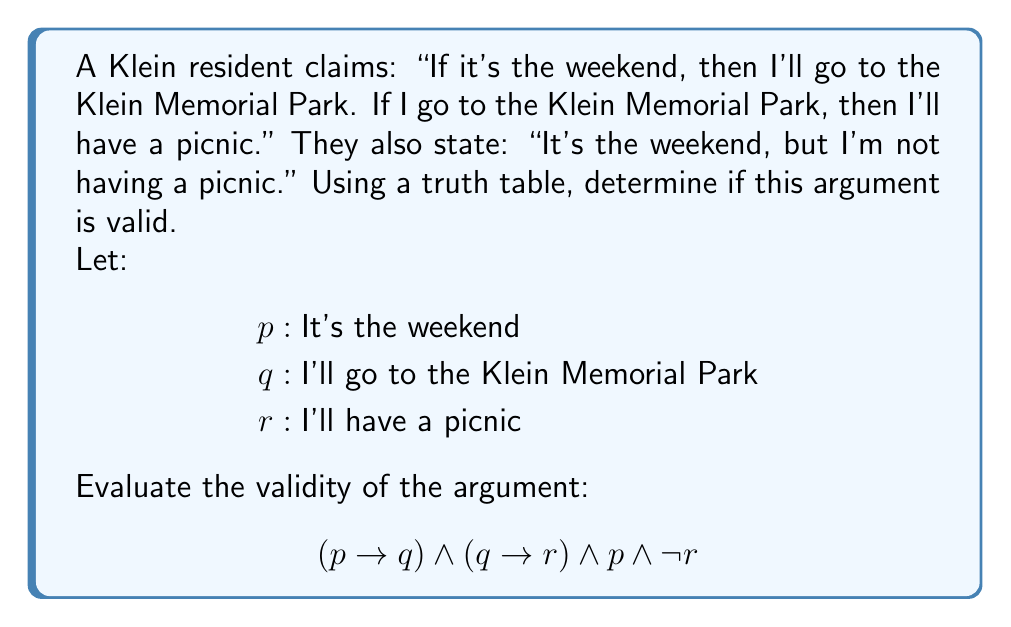What is the answer to this math problem? To determine the validity of this argument, we need to construct a truth table and examine if there's any case where all premises are true but the conclusion is false.

1. First, let's identify the premises and conclusion:
   Premises: $(p \rightarrow q)$, $(q \rightarrow r)$, $p$
   Conclusion: $\neg r$

2. Now, let's create a truth table with columns for $p$, $q$, $r$, $(p \rightarrow q)$, $(q \rightarrow r)$, and the entire statement:

   $$\begin{array}{|c|c|c|c|c|c|}
   \hline
   p & q & r & p \rightarrow q & q \rightarrow r & (p \rightarrow q) \land (q \rightarrow r) \land p \land \neg r \\
   \hline
   T & T & T & T & T & F \\
   T & T & F & T & F & F \\
   T & F & T & F & T & F \\
   T & F & F & F & T & F \\
   F & T & T & T & T & F \\
   F & T & F & T & F & F \\
   F & F & T & T & T & F \\
   F & F & F & T & T & F \\
   \hline
   \end{array}$$

3. Examine the truth table:
   - We're looking for rows where $(p \rightarrow q)$, $(q \rightarrow r)$, and $p$ are all true, and $r$ is false.
   - The only row that satisfies these conditions is the second row (T T F).

4. In this row:
   - $p$ is true (it's the weekend)
   - $q$ is true (I'll go to Klein Memorial Park)
   - $r$ is false (I'm not having a picnic)
   - $(p \rightarrow q)$ is true
   - $(q \rightarrow r)$ is false

5. The argument is invalid because in this case, all premises are true but the conclusion $(q \rightarrow r)$ is false.
Answer: The argument is invalid. There exists a scenario (when $p$ and $q$ are true, but $r$ is false) where all premises are true, but the conclusion $(q \rightarrow r)$ is false. 